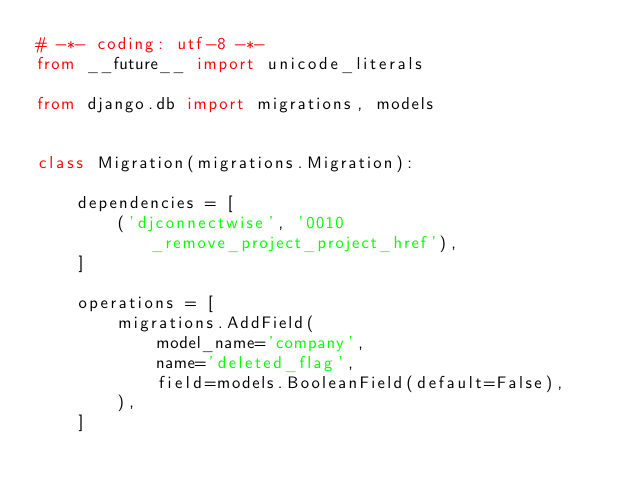<code> <loc_0><loc_0><loc_500><loc_500><_Python_># -*- coding: utf-8 -*-
from __future__ import unicode_literals

from django.db import migrations, models


class Migration(migrations.Migration):

    dependencies = [
        ('djconnectwise', '0010_remove_project_project_href'),
    ]

    operations = [
        migrations.AddField(
            model_name='company',
            name='deleted_flag',
            field=models.BooleanField(default=False),
        ),
    ]
</code> 